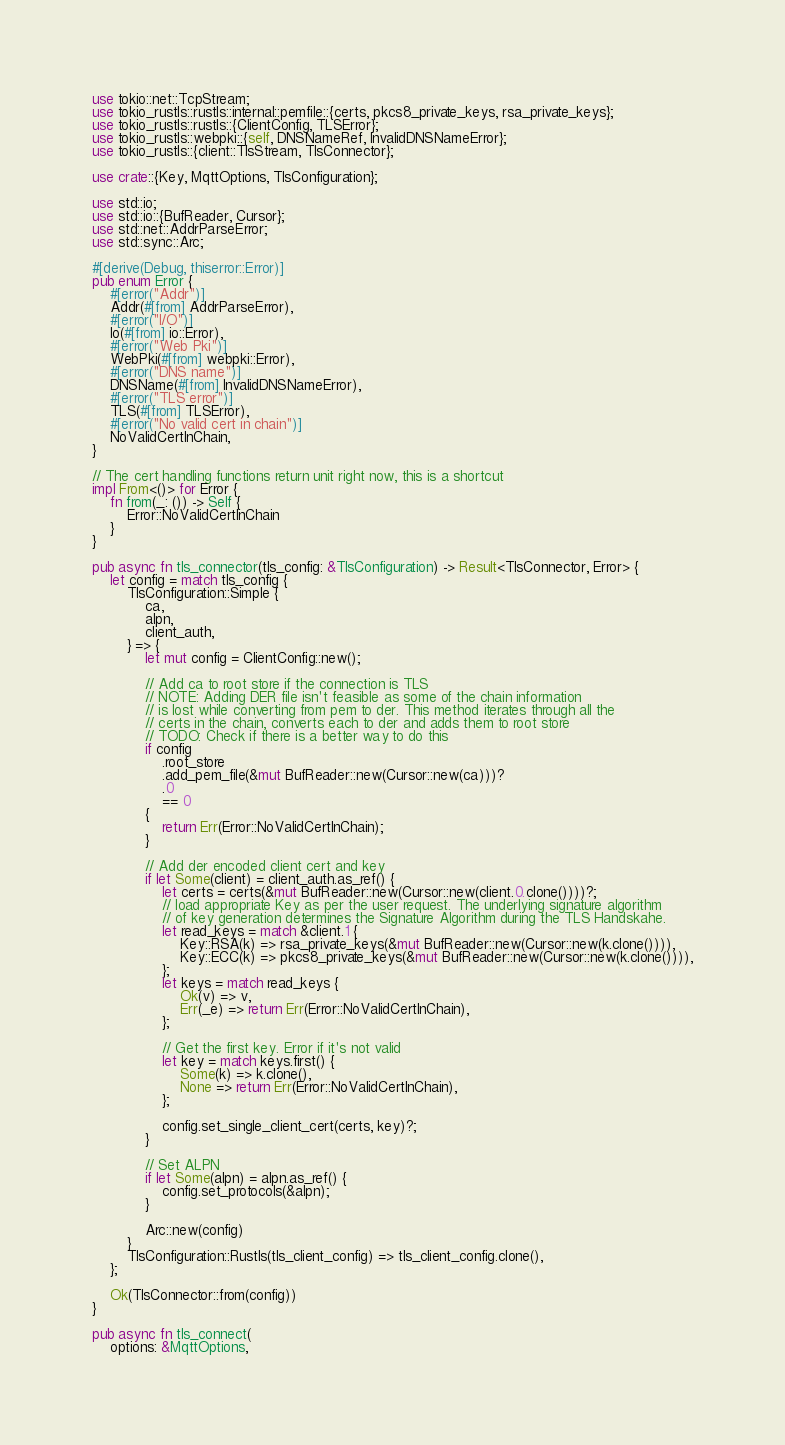Convert code to text. <code><loc_0><loc_0><loc_500><loc_500><_Rust_>use tokio::net::TcpStream;
use tokio_rustls::rustls::internal::pemfile::{certs, pkcs8_private_keys, rsa_private_keys};
use tokio_rustls::rustls::{ClientConfig, TLSError};
use tokio_rustls::webpki::{self, DNSNameRef, InvalidDNSNameError};
use tokio_rustls::{client::TlsStream, TlsConnector};

use crate::{Key, MqttOptions, TlsConfiguration};

use std::io;
use std::io::{BufReader, Cursor};
use std::net::AddrParseError;
use std::sync::Arc;

#[derive(Debug, thiserror::Error)]
pub enum Error {
    #[error("Addr")]
    Addr(#[from] AddrParseError),
    #[error("I/O")]
    Io(#[from] io::Error),
    #[error("Web Pki")]
    WebPki(#[from] webpki::Error),
    #[error("DNS name")]
    DNSName(#[from] InvalidDNSNameError),
    #[error("TLS error")]
    TLS(#[from] TLSError),
    #[error("No valid cert in chain")]
    NoValidCertInChain,
}

// The cert handling functions return unit right now, this is a shortcut
impl From<()> for Error {
    fn from(_: ()) -> Self {
        Error::NoValidCertInChain
    }
}

pub async fn tls_connector(tls_config: &TlsConfiguration) -> Result<TlsConnector, Error> {
    let config = match tls_config {
        TlsConfiguration::Simple {
            ca,
            alpn,
            client_auth,
        } => {
            let mut config = ClientConfig::new();

            // Add ca to root store if the connection is TLS
            // NOTE: Adding DER file isn't feasible as some of the chain information
            // is lost while converting from pem to der. This method iterates through all the
            // certs in the chain, converts each to der and adds them to root store
            // TODO: Check if there is a better way to do this
            if config
                .root_store
                .add_pem_file(&mut BufReader::new(Cursor::new(ca)))?
                .0
                == 0
            {
                return Err(Error::NoValidCertInChain);
            }

            // Add der encoded client cert and key
            if let Some(client) = client_auth.as_ref() {
                let certs = certs(&mut BufReader::new(Cursor::new(client.0.clone())))?;
                // load appropriate Key as per the user request. The underlying signature algorithm
                // of key generation determines the Signature Algorithm during the TLS Handskahe.
                let read_keys = match &client.1 {
                    Key::RSA(k) => rsa_private_keys(&mut BufReader::new(Cursor::new(k.clone()))),
                    Key::ECC(k) => pkcs8_private_keys(&mut BufReader::new(Cursor::new(k.clone()))),
                };
                let keys = match read_keys {
                    Ok(v) => v,
                    Err(_e) => return Err(Error::NoValidCertInChain),
                };

                // Get the first key. Error if it's not valid
                let key = match keys.first() {
                    Some(k) => k.clone(),
                    None => return Err(Error::NoValidCertInChain),
                };

                config.set_single_client_cert(certs, key)?;
            }

            // Set ALPN
            if let Some(alpn) = alpn.as_ref() {
                config.set_protocols(&alpn);
            }

            Arc::new(config)
        }
        TlsConfiguration::Rustls(tls_client_config) => tls_client_config.clone(),
    };

    Ok(TlsConnector::from(config))
}

pub async fn tls_connect(
    options: &MqttOptions,</code> 